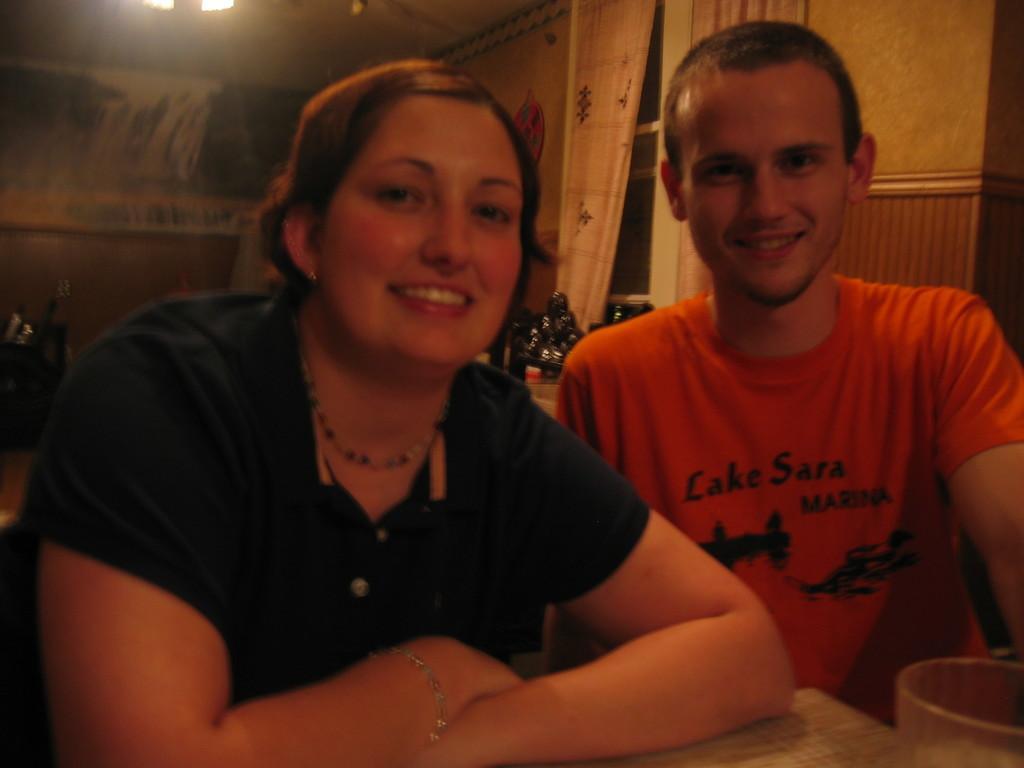How would you summarize this image in a sentence or two? This picture might be taken inside the room. In this image, we can see two people man and woman are sitting on chair in front of the table. On that table, we can see a glass and a cloth. In the background, we can see curtains, glass windows. On the top there is a roof with few lights. 